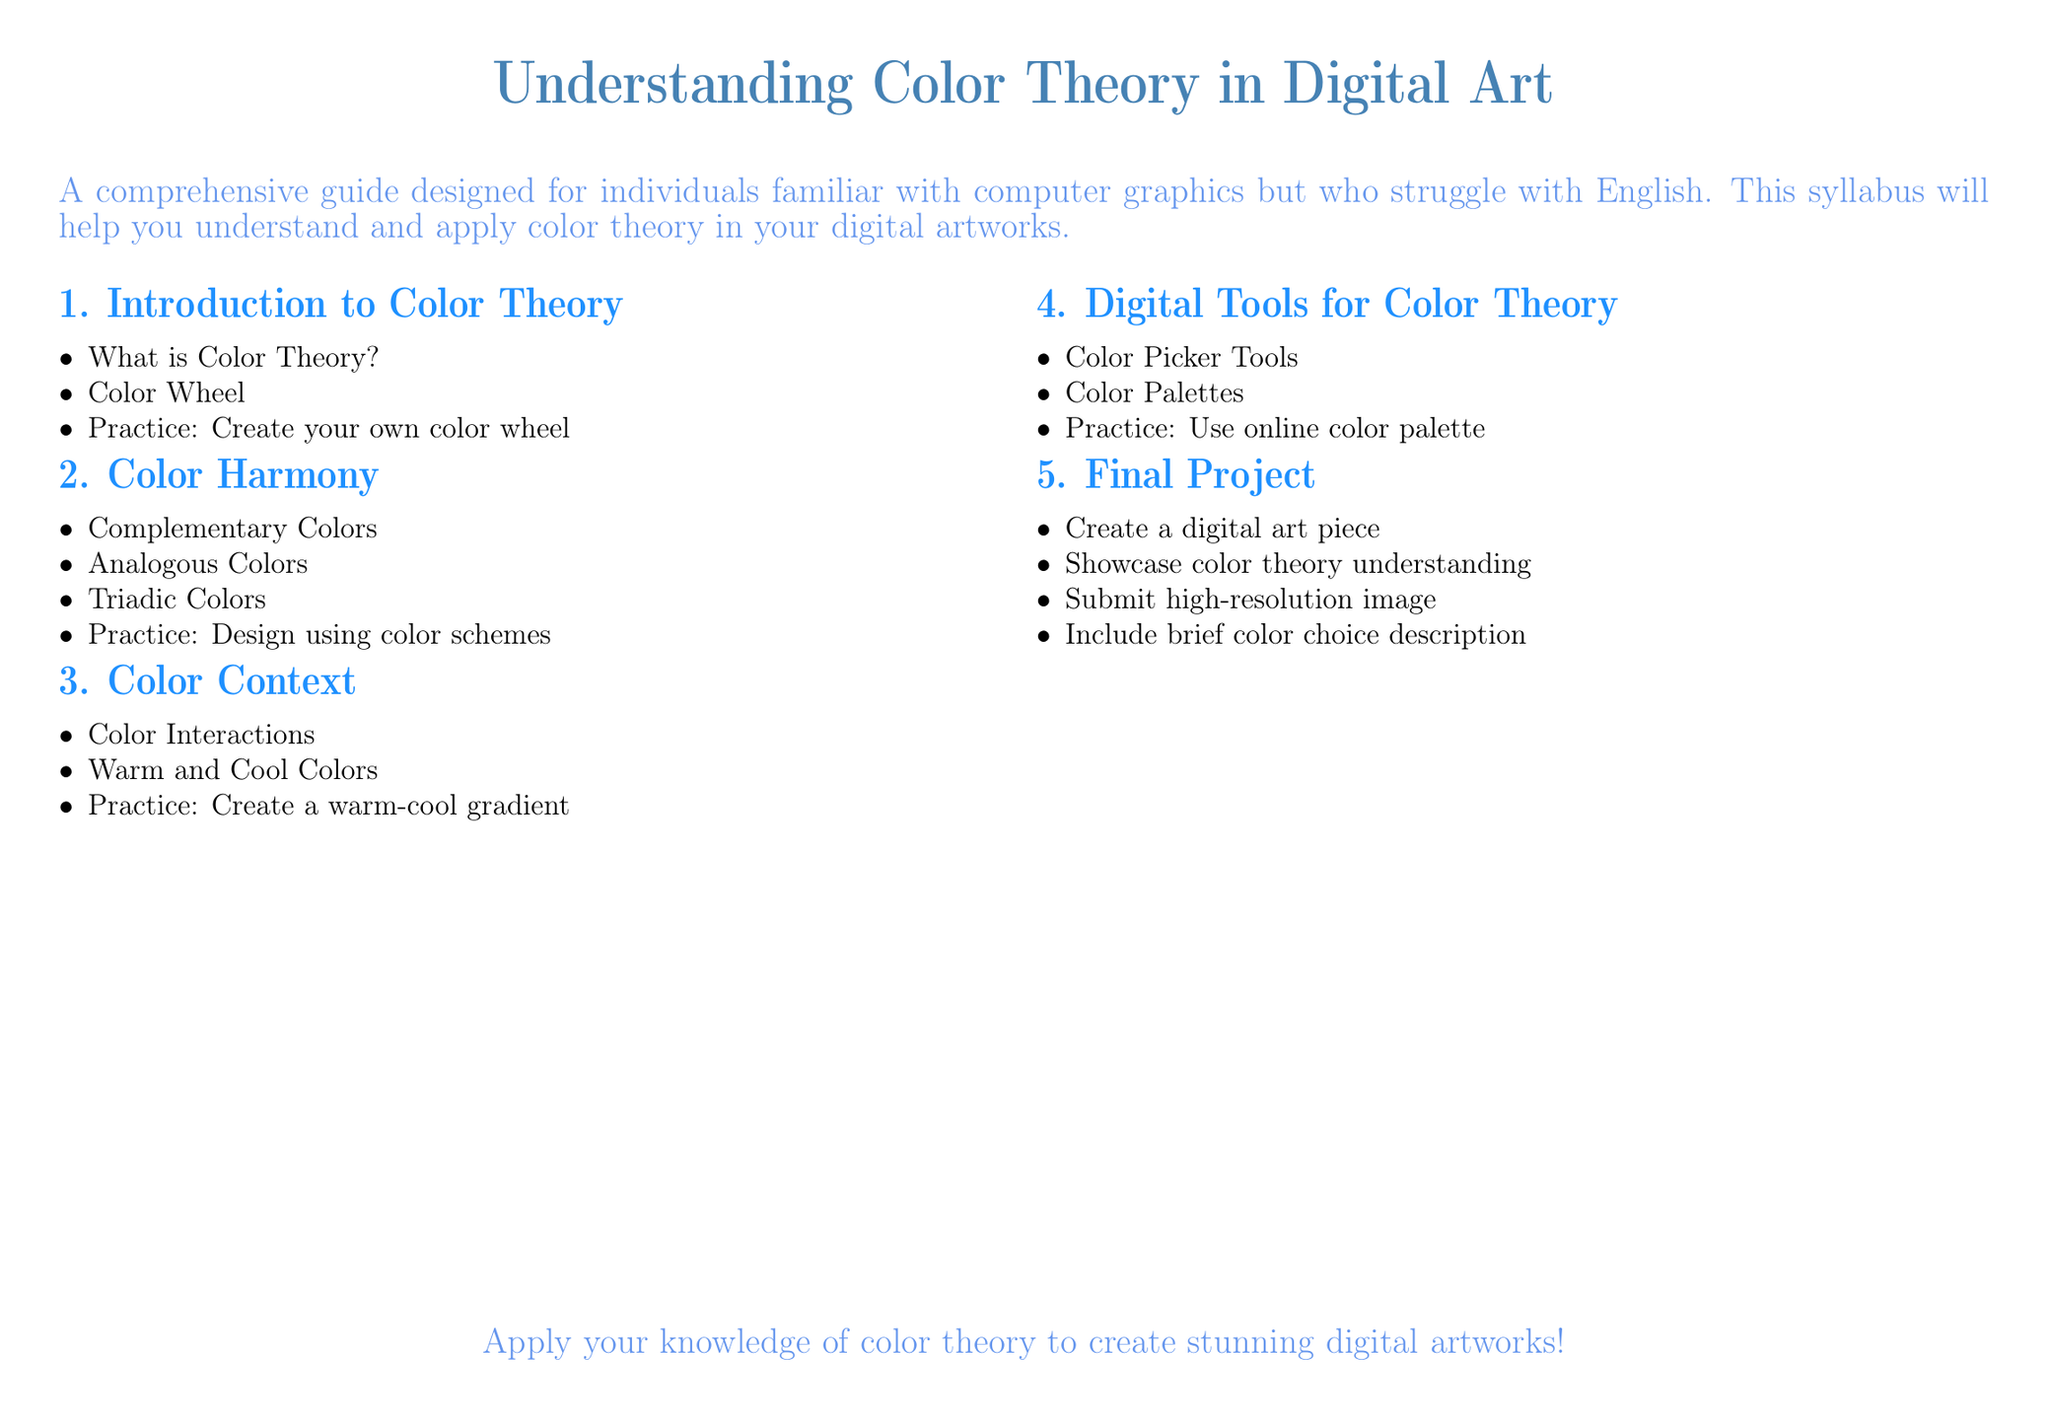What is the title of the document? The title is prominently displayed at the top of the document, which concerns color theory in digital art.
Answer: Understanding Color Theory in Digital Art How many modules are in the syllabus? The syllabus is divided into five distinct modules.
Answer: 5 What is the first module about? The first module introduces basic concepts of color, providing foundational knowledge in color theory.
Answer: Introduction to Color Theory What is the practice exercise for the second module? The second module focuses on color harmony and includes a specific design task.
Answer: Design using color schemes What color types are included in the third module? The third module discusses different temperatures of colors, which are fundamental in color perception.
Answer: Warm and Cool Colors What tool is mentioned in the fourth module? The fourth module emphasizes tools that assist in selecting and managing colors in digital art applications.
Answer: Color Picker Tools What type of art piece is required for the final project? The final project requires participants to create a specific type of digital artwork that demonstrates their understanding.
Answer: Digital art piece Is there a description requirement for the final project? The final project includes submission requirements, which specify additional documentation about the artwork.
Answer: Brief color choice description What is the purpose of the syllabus? The syllabus aims to educate individuals with basic graphic knowledge to effectively apply color theory in their art.
Answer: Apply your knowledge of color theory to create stunning digital artworks! 